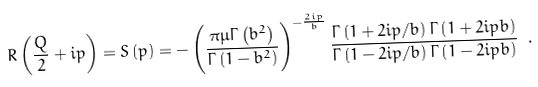Convert formula to latex. <formula><loc_0><loc_0><loc_500><loc_500>R \left ( \frac { Q } { 2 } + i p \right ) = S \left ( p \right ) = - \left ( \frac { \pi \mu \Gamma \left ( b ^ { 2 } \right ) } { \Gamma \left ( 1 - b ^ { 2 } \right ) } \right ) ^ { - \frac { 2 i p } { b } } \frac { \Gamma \left ( 1 + 2 i p / b \right ) \Gamma \left ( 1 + 2 i p b \right ) } { \Gamma \left ( 1 - 2 i p / b \right ) \Gamma \left ( 1 - 2 i p b \right ) } \ .</formula> 